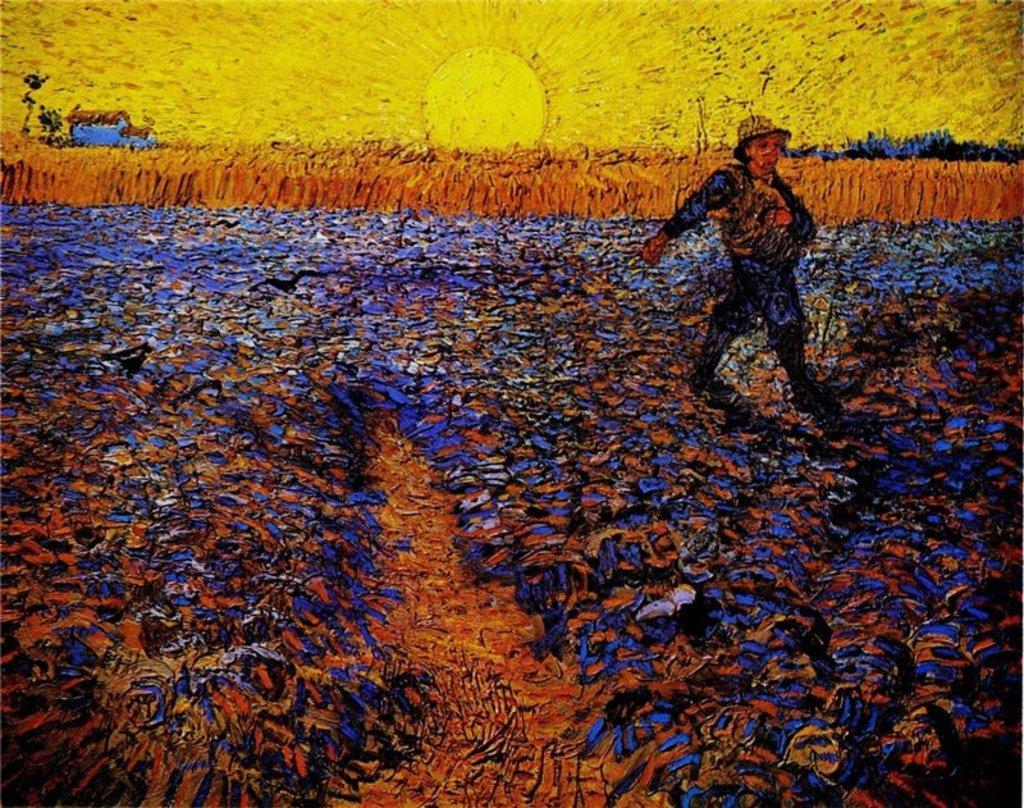How would you summarize this image in a sentence or two? There is some artwork and there is a sunrise, crops and in the front a person is walking in between the crops. 